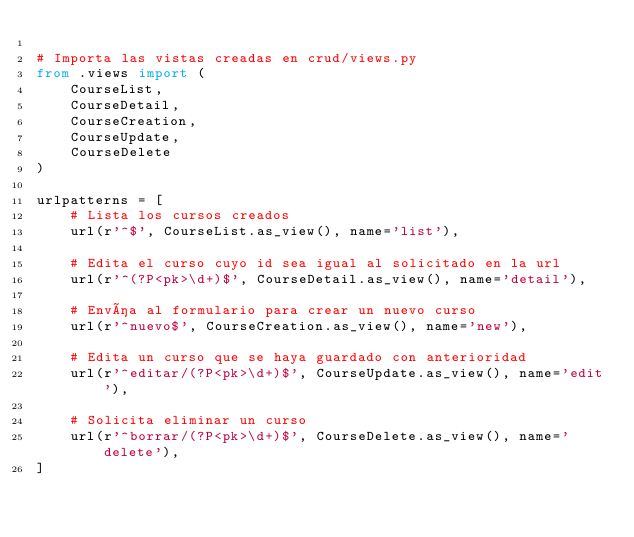<code> <loc_0><loc_0><loc_500><loc_500><_Python_>
# Importa las vistas creadas en crud/views.py
from .views import (
    CourseList,
    CourseDetail,
    CourseCreation,
    CourseUpdate,
    CourseDelete
)

urlpatterns = [
    # Lista los cursos creados
    url(r'^$', CourseList.as_view(), name='list'),
    
    # Edita el curso cuyo id sea igual al solicitado en la url
    url(r'^(?P<pk>\d+)$', CourseDetail.as_view(), name='detail'),

    # Envía al formulario para crear un nuevo curso
    url(r'^nuevo$', CourseCreation.as_view(), name='new'),
    
    # Edita un curso que se haya guardado con anterioridad
    url(r'^editar/(?P<pk>\d+)$', CourseUpdate.as_view(), name='edit'),

    # Solicita eliminar un curso
    url(r'^borrar/(?P<pk>\d+)$', CourseDelete.as_view(), name='delete'),
]
</code> 